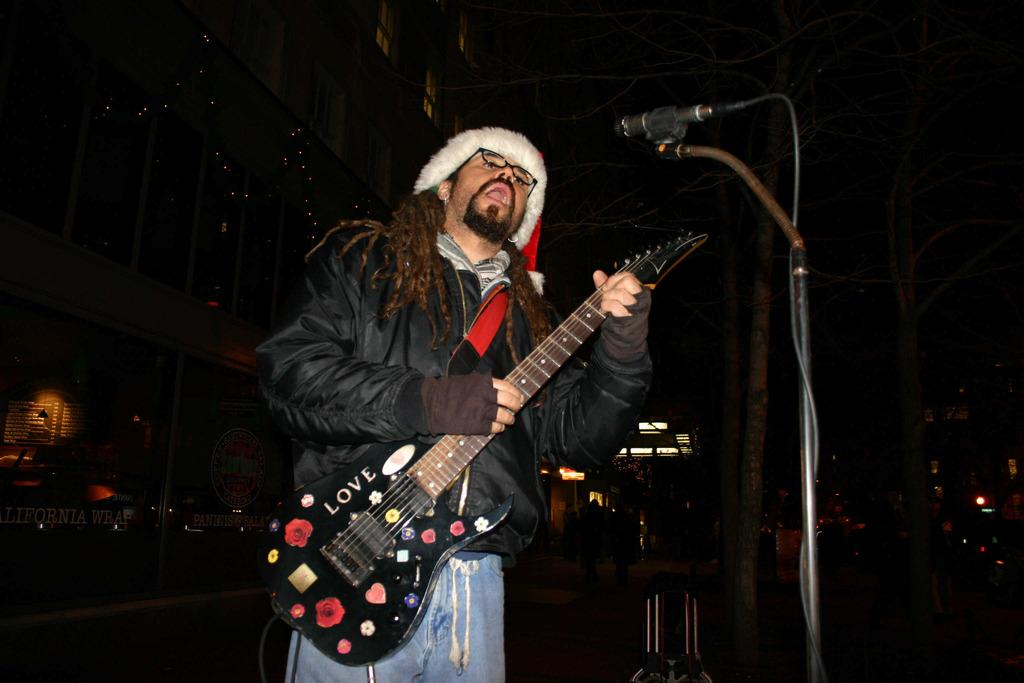What is the man in the image doing? The man is playing a guitar and singing. How is the man's voice being amplified in the image? The man is using a microphone. What is the plot of the story being told by the man in the image? There is no story being told in the image; the man is simply playing a guitar and singing. Can you see a mitten in the image? No, there is no mitten present in the image. 